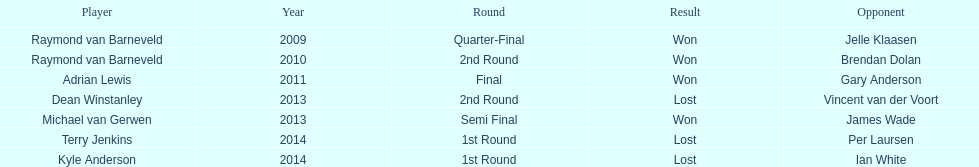Write the full table. {'header': ['Player', 'Year', 'Round', 'Result', 'Opponent'], 'rows': [['Raymond van Barneveld', '2009', 'Quarter-Final', 'Won', 'Jelle Klaasen'], ['Raymond van Barneveld', '2010', '2nd Round', 'Won', 'Brendan Dolan'], ['Adrian Lewis', '2011', 'Final', 'Won', 'Gary Anderson'], ['Dean Winstanley', '2013', '2nd Round', 'Lost', 'Vincent van der Voort'], ['Michael van Gerwen', '2013', 'Semi Final', 'Won', 'James Wade'], ['Terry Jenkins', '2014', '1st Round', 'Lost', 'Per Laursen'], ['Kyle Anderson', '2014', '1st Round', 'Lost', 'Ian White']]} Did terry jenkins or per laursen win in 2014? Per Laursen. 